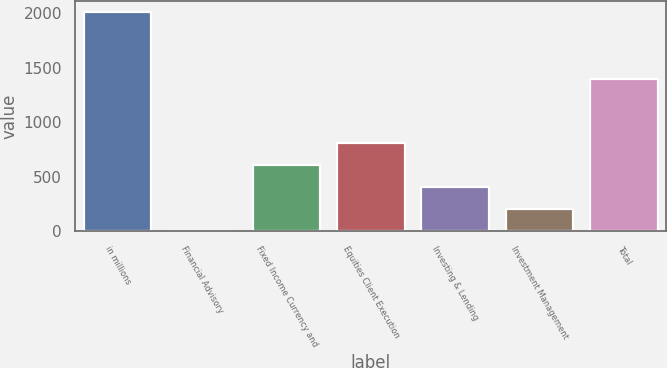<chart> <loc_0><loc_0><loc_500><loc_500><bar_chart><fcel>in millions<fcel>Financial Advisory<fcel>Fixed Income Currency and<fcel>Equities Client Execution<fcel>Investing & Lending<fcel>Investment Management<fcel>Total<nl><fcel>2012<fcel>1<fcel>604.3<fcel>805.4<fcel>403.2<fcel>202.1<fcel>1397<nl></chart> 